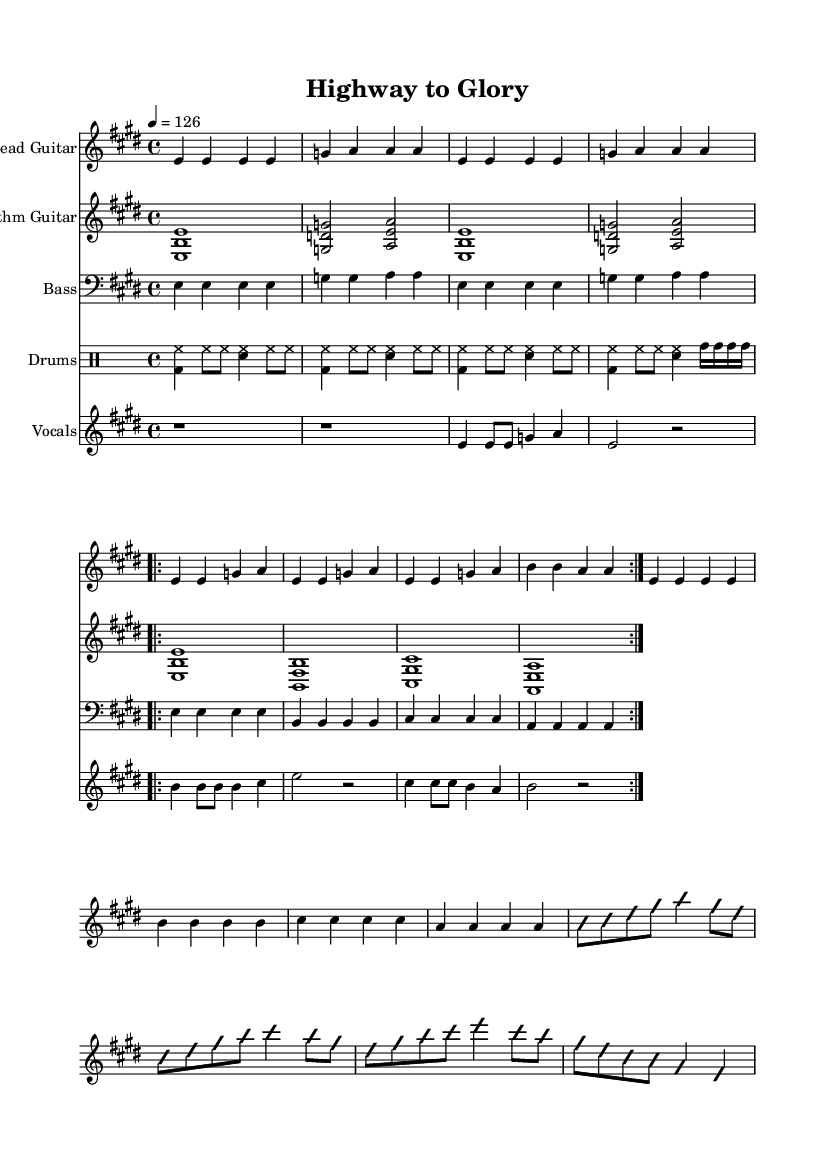What is the key signature of this music? The key signature shows two sharps (F# and C#), indicating that the piece is set in E major.
Answer: E major What is the time signature? The time signature is indicated at the beginning as 4/4, meaning there are four beats per measure.
Answer: 4/4 What is the tempo of the piece? The tempo marking is given as "4 = 126", which indicates a moderately fast tempo of 126 beats per minute.
Answer: 126 How many sections are in the verse of the music? The verse section is marked "repeat volta 2," which indicates it should be played two times, making it a total of two repeated verses.
Answer: 2 What genre does this piece belong to? The overall style and instrumentation, along with the song's title referencing "Highway," suggest it is classified under classic rock.
Answer: Classic rock What instruments are featured in this sheet music? The score includes lead guitar, rhythm guitar, bass, drums, and vocals, which are typical of a rock band setup.
Answer: Lead guitar, rhythm guitar, bass, drums, and vocals What is the main theme conveyed in the lyrics? The lyrics refer to a journey or pursuit, specifically mentioning a "highway to glory," which embodies themes of aspiration and achievement.
Answer: Aspiration 